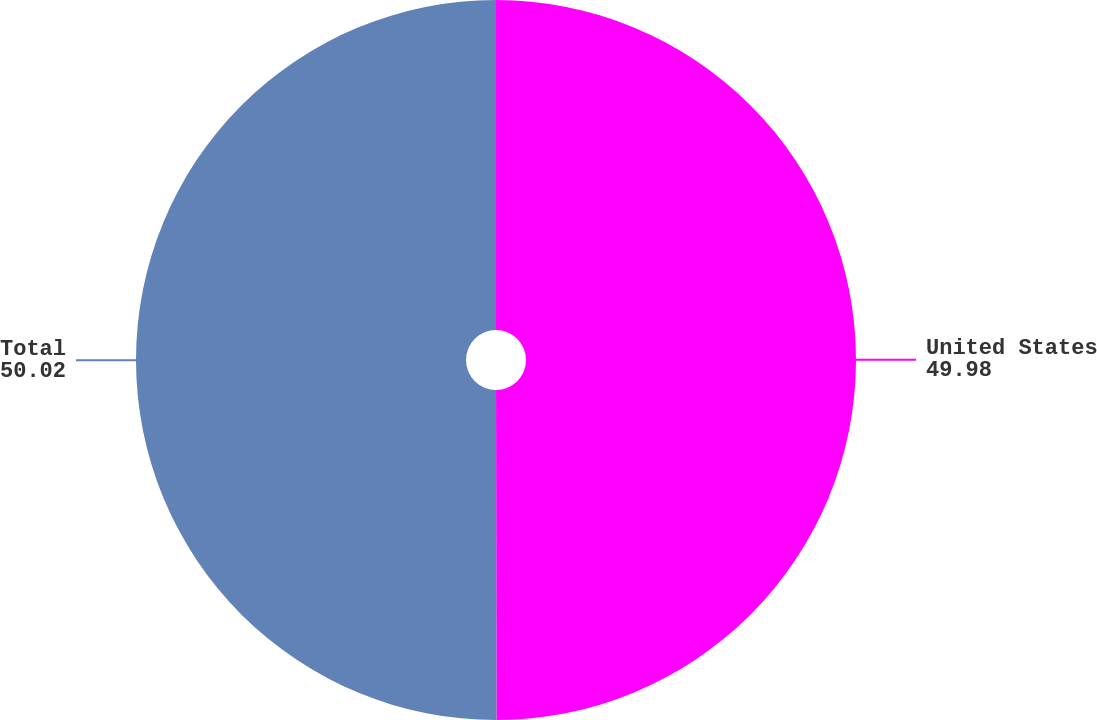Convert chart. <chart><loc_0><loc_0><loc_500><loc_500><pie_chart><fcel>United States<fcel>Total<nl><fcel>49.98%<fcel>50.02%<nl></chart> 